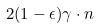<formula> <loc_0><loc_0><loc_500><loc_500>2 ( 1 - \epsilon ) \gamma \cdot n</formula> 